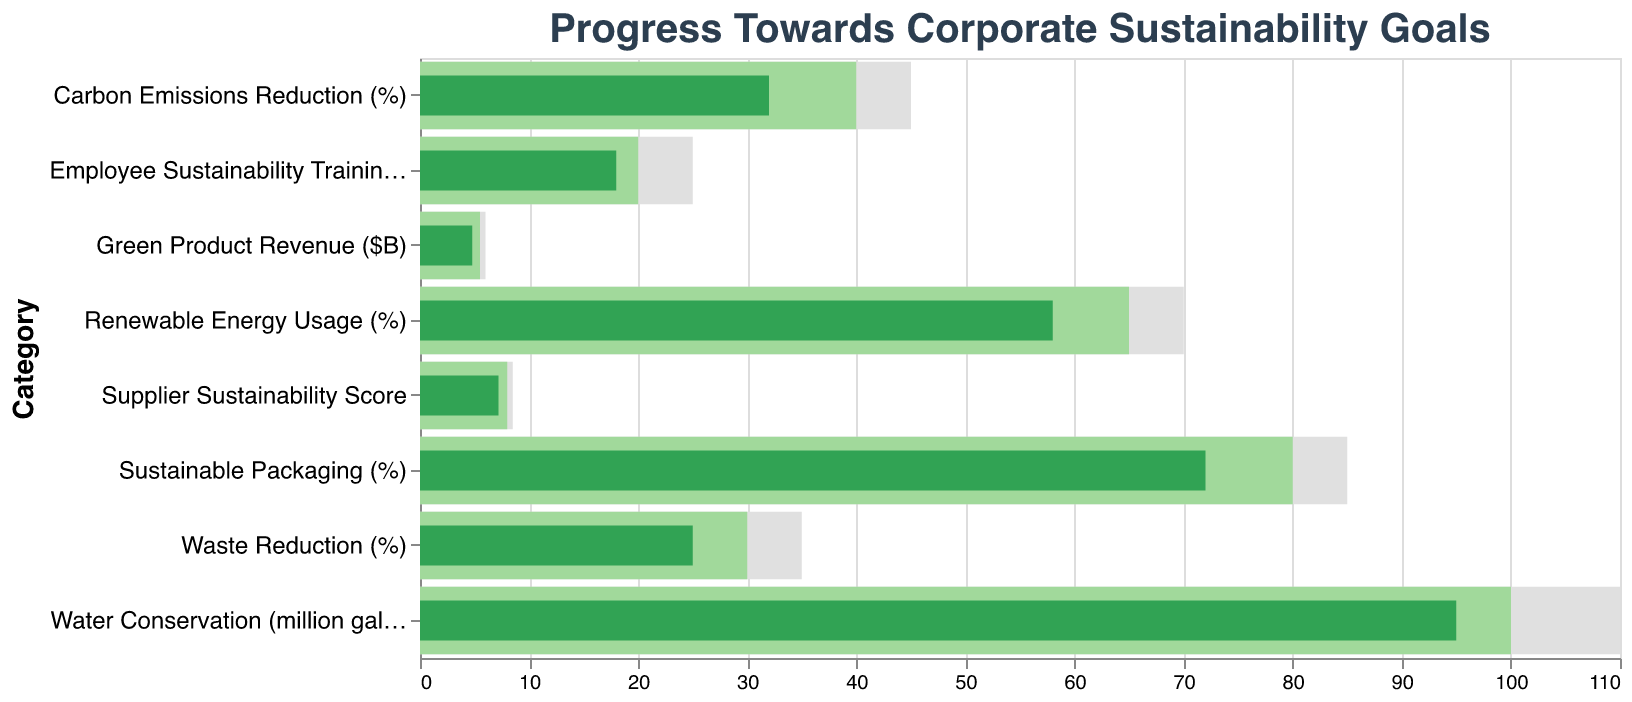What is the title of the chart? The title of the chart is displayed at the top of the figure and reads "Progress Towards Corporate Sustainability Goals".
Answer: Progress Towards Corporate Sustainability Goals How many sustainability categories are tracked in the chart? There are eight distinct categories listed on the y-axis of the chart.
Answer: Eight Which category has the highest actual value? By looking at the green bars representing the actual values, we see that "Sustainable Packaging (%)" has the highest actual value at 72%.
Answer: Sustainable Packaging (%) Which category has the largest gap between its actual value and its target value? To find this, subtract the actual values from the target values for each category and identify the largest difference. The largest gap is in "Green Product Revenue ($B)" with a difference of 0.7 billion dollars (5.5 - 4.8).
Answer: Green Product Revenue ($B) Are there any categories where the actual value surpasses the target value? By comparing the heights of the green bars (actual) against the light green bars (target), none of the actual values surpass the target values in the chart.
Answer: No What is the difference between the actual and comparison value for Water Conservation? Subtract the actual value for Water Conservation (95 million gallons) from its comparison value (110 million gallons), resulting in 110 - 95 = 15 million gallons.
Answer: 15 million gallons How does the actual value of Employee Sustainability Training compare to its target value? The actual value for Employee Sustainability Training is 18 hours, while the target value is 20 hours. Thus, the actual value is less than the target value by 2 hours.
Answer: 2 hours less What is the average of the target values for Carbon Emissions Reduction and Waste Reduction? Add the target values for Carbon Emissions Reduction (40%) and Waste Reduction (30%), then divide by 2. (40 + 30) / 2 = 35%.
Answer: 35% Which category has the smallest actual value? By observing the green bars, the "Supplier Sustainability Score" has the smallest actual value at 7.2.
Answer: Supplier Sustainability Score What is the total target value for categories related to percentage metrics? Sum the target values of all percentage-based categories: Carbon Emissions Reduction (40), Renewable Energy Usage (65), Waste Reduction (30), Sustainable Packaging (80). The total is 40 + 65 + 30 + 80 = 215.
Answer: 215 